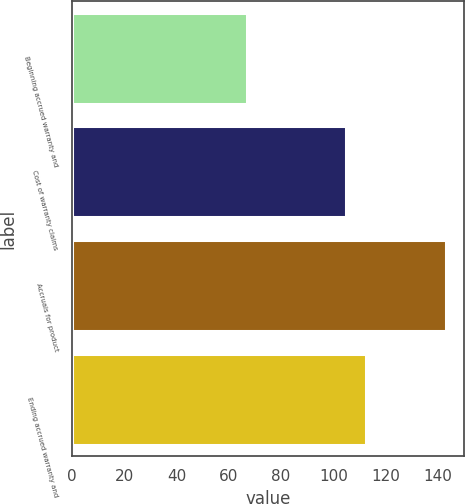Convert chart to OTSL. <chart><loc_0><loc_0><loc_500><loc_500><bar_chart><fcel>Beginning accrued warranty and<fcel>Cost of warranty claims<fcel>Accruals for product<fcel>Ending accrued warranty and<nl><fcel>67<fcel>105<fcel>143<fcel>112.6<nl></chart> 